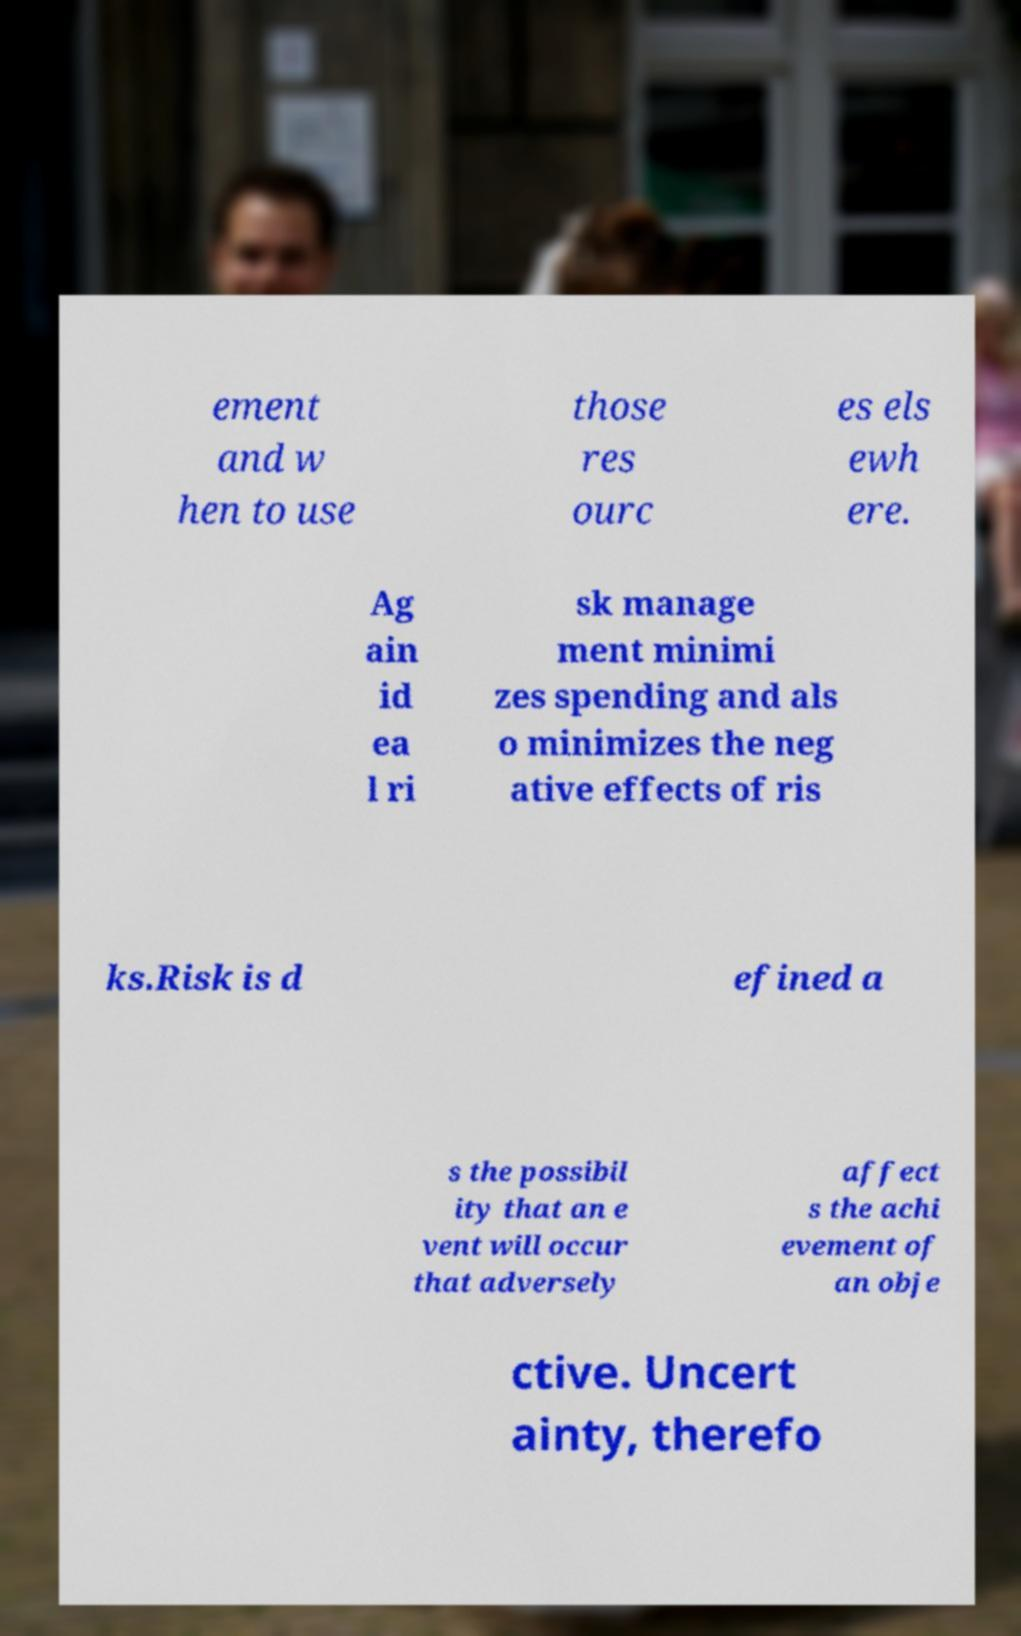I need the written content from this picture converted into text. Can you do that? ement and w hen to use those res ourc es els ewh ere. Ag ain id ea l ri sk manage ment minimi zes spending and als o minimizes the neg ative effects of ris ks.Risk is d efined a s the possibil ity that an e vent will occur that adversely affect s the achi evement of an obje ctive. Uncert ainty, therefo 